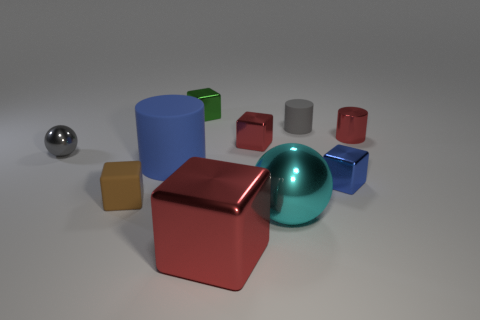Subtract all red cubes. How many were subtracted if there are1red cubes left? 1 Subtract all cylinders. How many objects are left? 7 Subtract all big cyan shiny cylinders. Subtract all shiny balls. How many objects are left? 8 Add 9 small brown rubber cubes. How many small brown rubber cubes are left? 10 Add 4 tiny yellow spheres. How many tiny yellow spheres exist? 4 Subtract 0 yellow spheres. How many objects are left? 10 